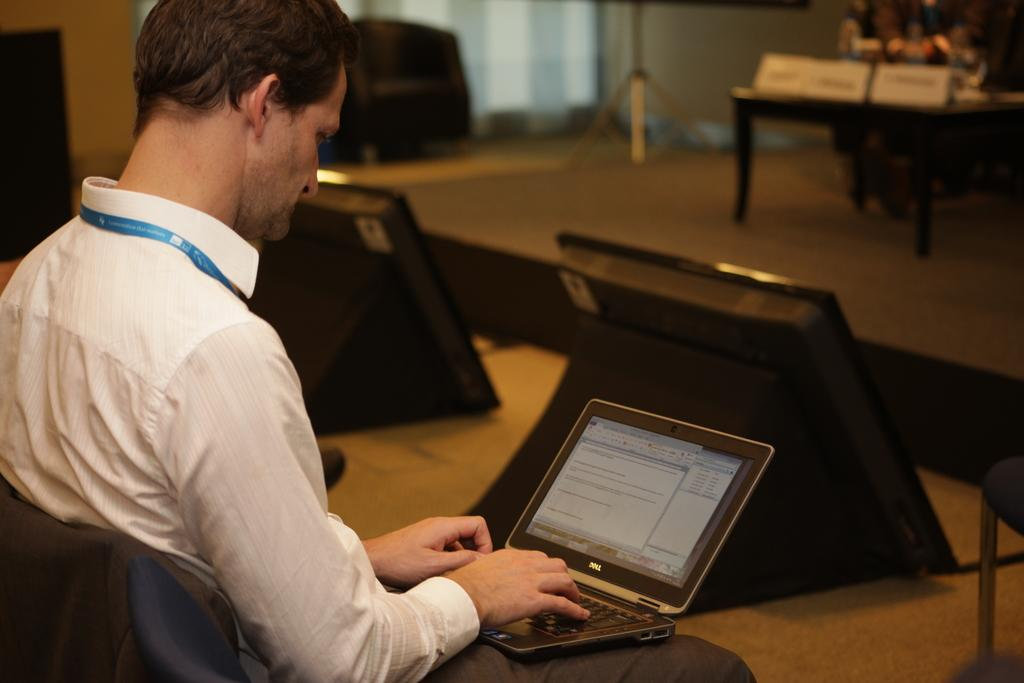What is the man in the image doing? The man is sitting on a chair in the image. What object is in front of the man? There is a laptop in front of the man. Can you describe any furniture in the image? There is a table visible in the top right side of the image. How would you describe the background of the image? The background of the image is partially blurred. What type of lunch is the man eating in the image? There is no lunch present in the image; the man is sitting with a laptop in front of him. 